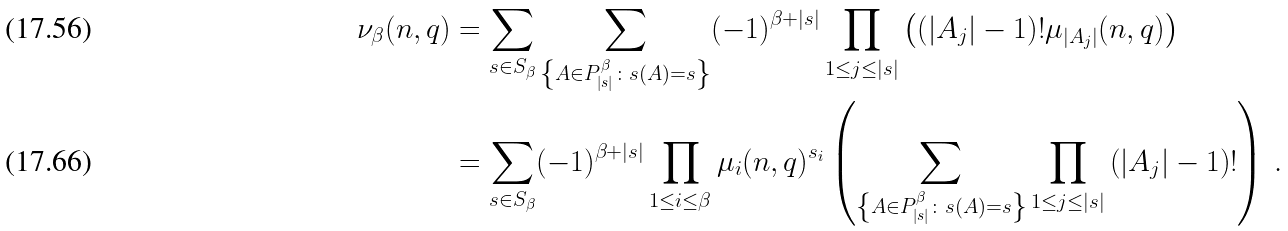<formula> <loc_0><loc_0><loc_500><loc_500>\nu _ { \beta } ( n , q ) & = \sum _ { s \in S _ { \beta } } \sum _ { \left \{ A \in P ^ { \beta } _ { | s | } \colon s ( A ) = s \right \} } ( - 1 ) ^ { \beta + | s | } \prod _ { 1 \leq j \leq | s | } \left ( \left ( | A _ { j } | - 1 \right ) ! \mu _ { | A _ { j } | } ( n , q ) \right ) \\ & = \sum _ { s \in S _ { \beta } } ( - 1 ) ^ { \beta + | s | } \prod _ { 1 \leq i \leq \beta } \mu _ { i } ( n , q ) ^ { s _ { i } } \left ( \sum _ { \left \{ A \in P ^ { \beta } _ { | s | } \colon s ( A ) = s \right \} } \prod _ { 1 \leq j \leq | s | } \left ( | A _ { j } | - 1 \right ) ! \right ) \, .</formula> 